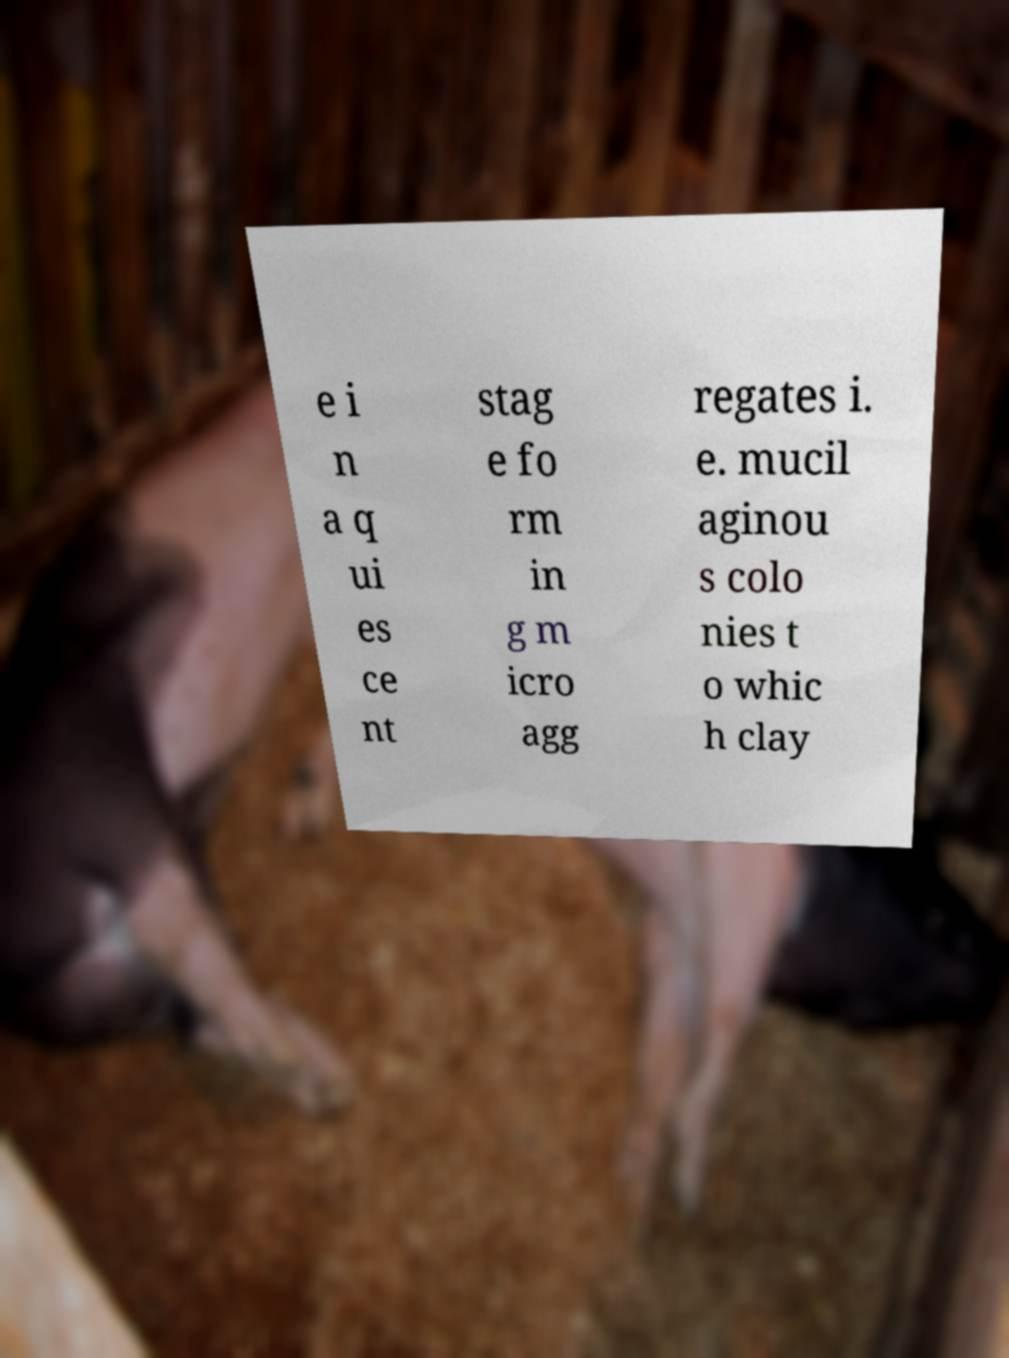I need the written content from this picture converted into text. Can you do that? e i n a q ui es ce nt stag e fo rm in g m icro agg regates i. e. mucil aginou s colo nies t o whic h clay 